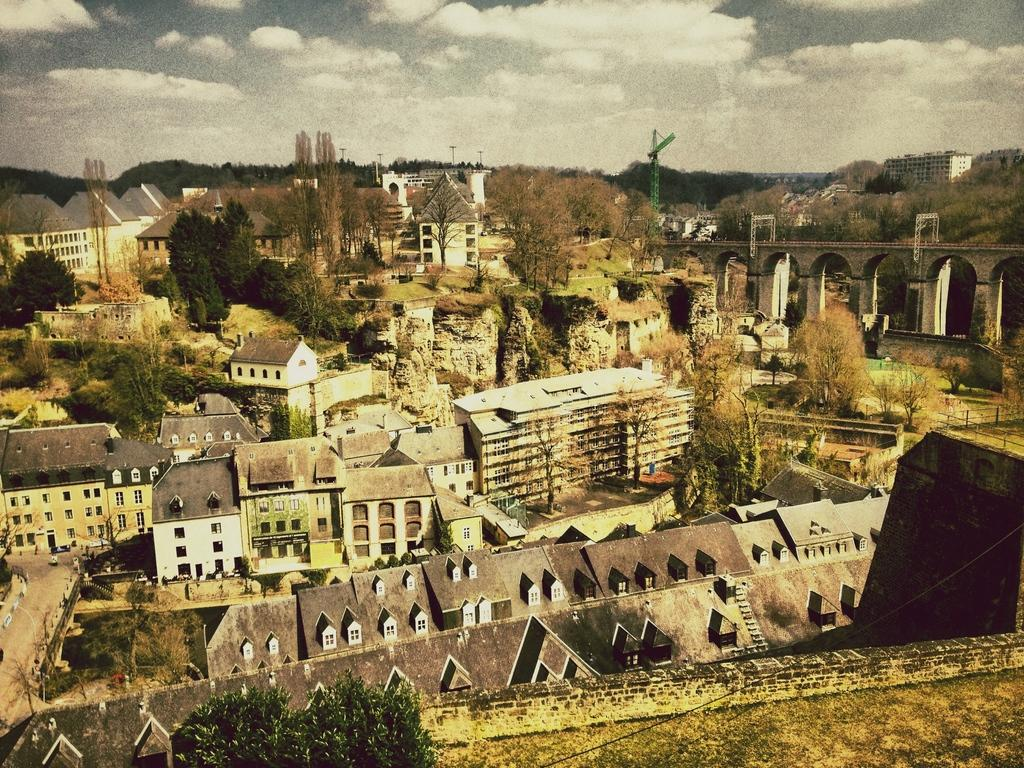What type of structures can be seen in the image? There are buildings in the image. What natural elements are present in the image? There are trees in the image. What man-made objects can be seen in the image? There are poles and a crane in the image. What type of infrastructure is visible in the image? There is a bridge in the image. What type of wood is used to build the wren's nest in the image? There is no wren or nest present in the image, so we cannot determine the type of wood used. What month is it in the image? The image does not provide any information about the month or time of year. 